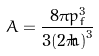Convert formula to latex. <formula><loc_0><loc_0><loc_500><loc_500>A = \frac { 8 \pi p _ { f } ^ { 3 } } { 3 ( 2 \pi \hbar { ) } ^ { 3 } }</formula> 